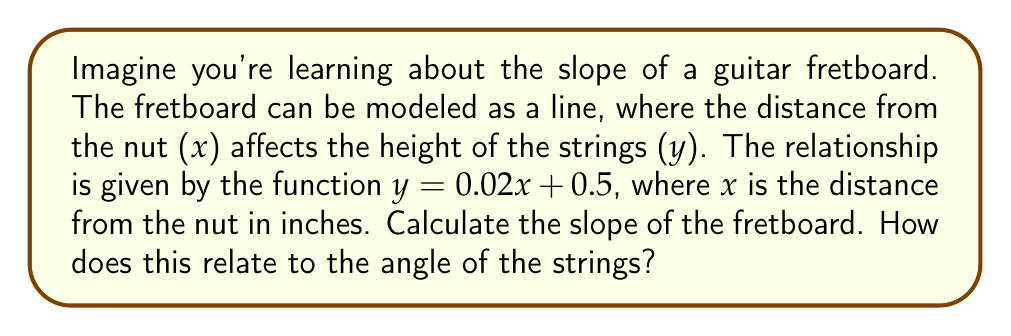Teach me how to tackle this problem. Let's approach this step-by-step to make it less intimidating:

1) The function given is $y = 0.02x + 0.5$. This is in the form of a linear equation $y = mx + b$, where:
   - $m$ is the slope
   - $b$ is the y-intercept

2) In this case, we can see that:
   - $m = 0.02$
   - $b = 0.5$

3) The slope of a line is always represented by the coefficient of x in a linear equation. So, the slope of the fretboard is 0.02.

4) To understand what this means:
   - For every 1 inch you move along the fretboard (in the x direction), the height increases by 0.02 inches.

5) To relate this to the angle of the strings:
   - The slope of a line is equal to the tangent of the angle it makes with the horizontal.
   - So, $\tan(\theta) = 0.02$, where $\theta$ is the angle of the strings with the horizontal.

6) To find this angle, we would use the inverse tangent (arctangent) function:
   $\theta = \arctan(0.02) \approx 1.15°$

This means the strings form a very small angle (about 1.15 degrees) with the fretboard, which is why the slope feels almost flat when you're playing.
Answer: Slope = 0.02 